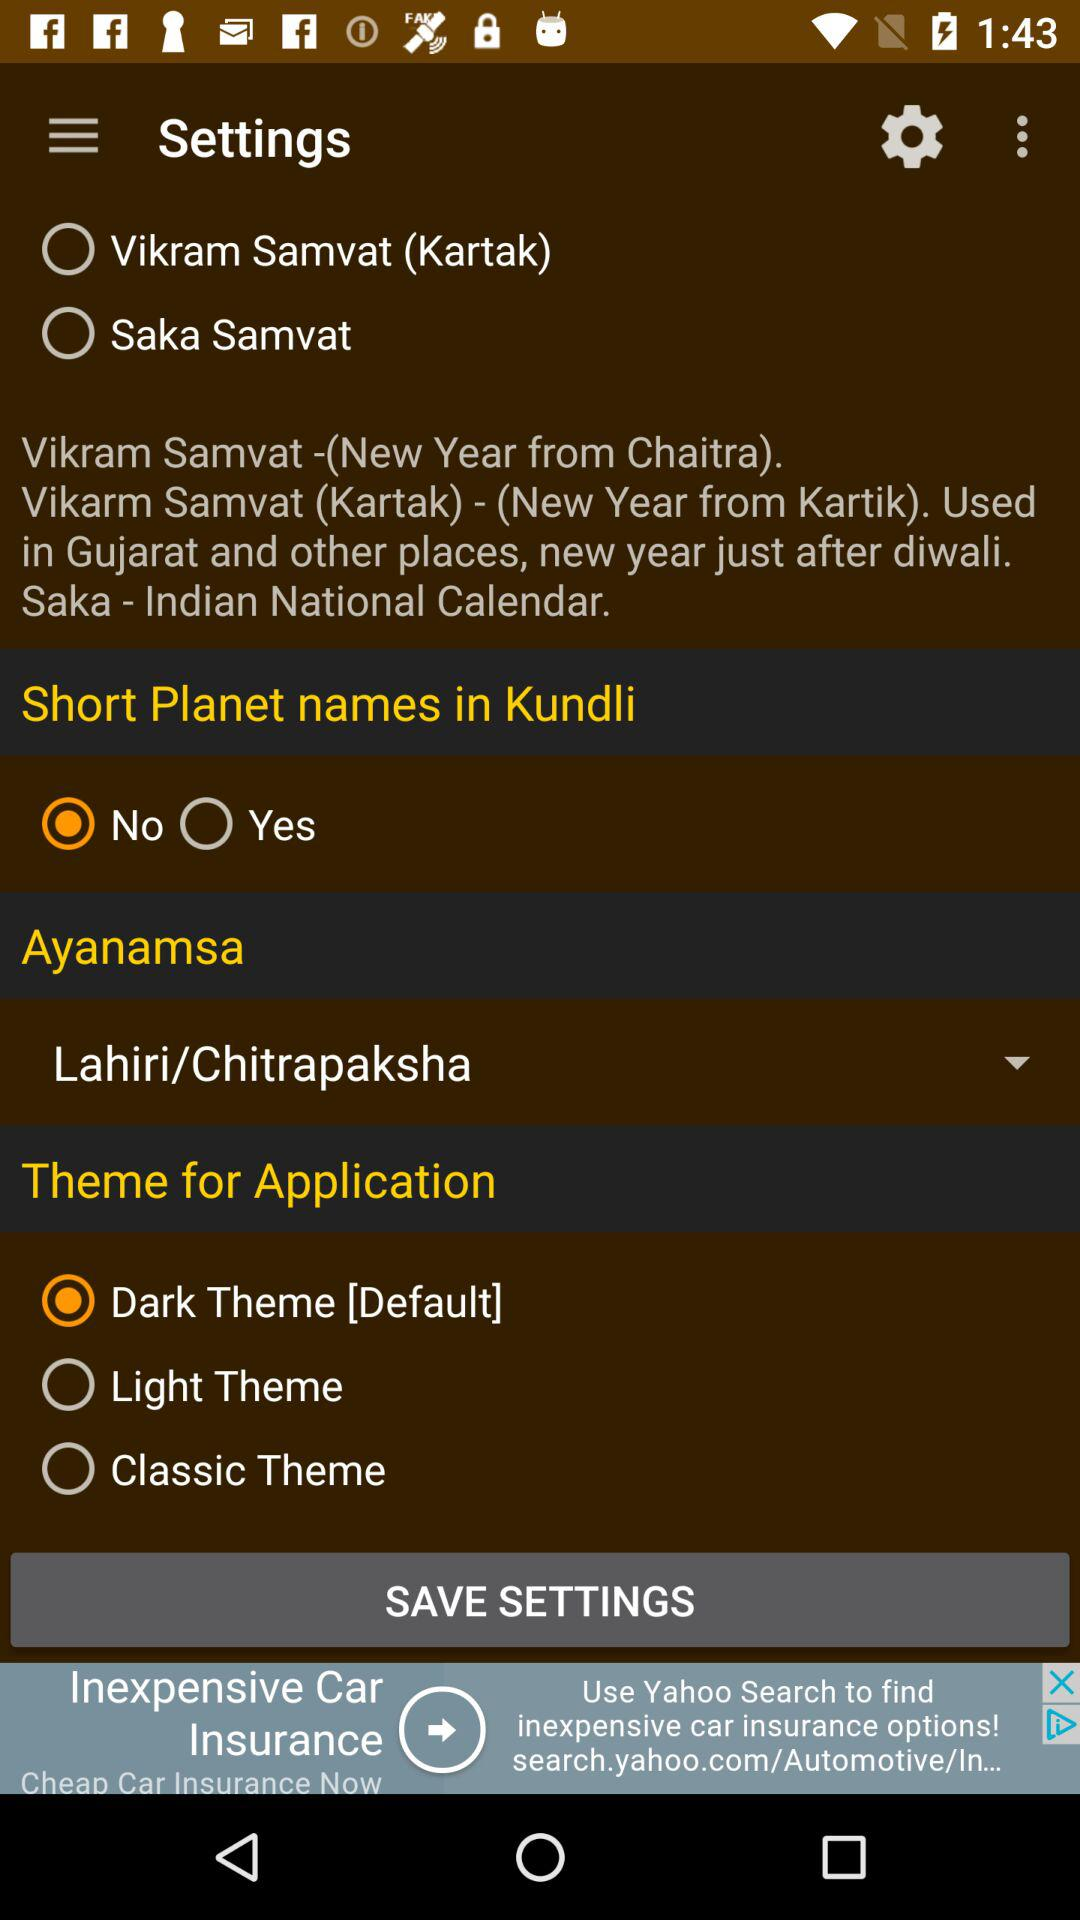Which ayanamsa is selected? The selected ayanamsa is "Lahiri/Chitrapaksha". 